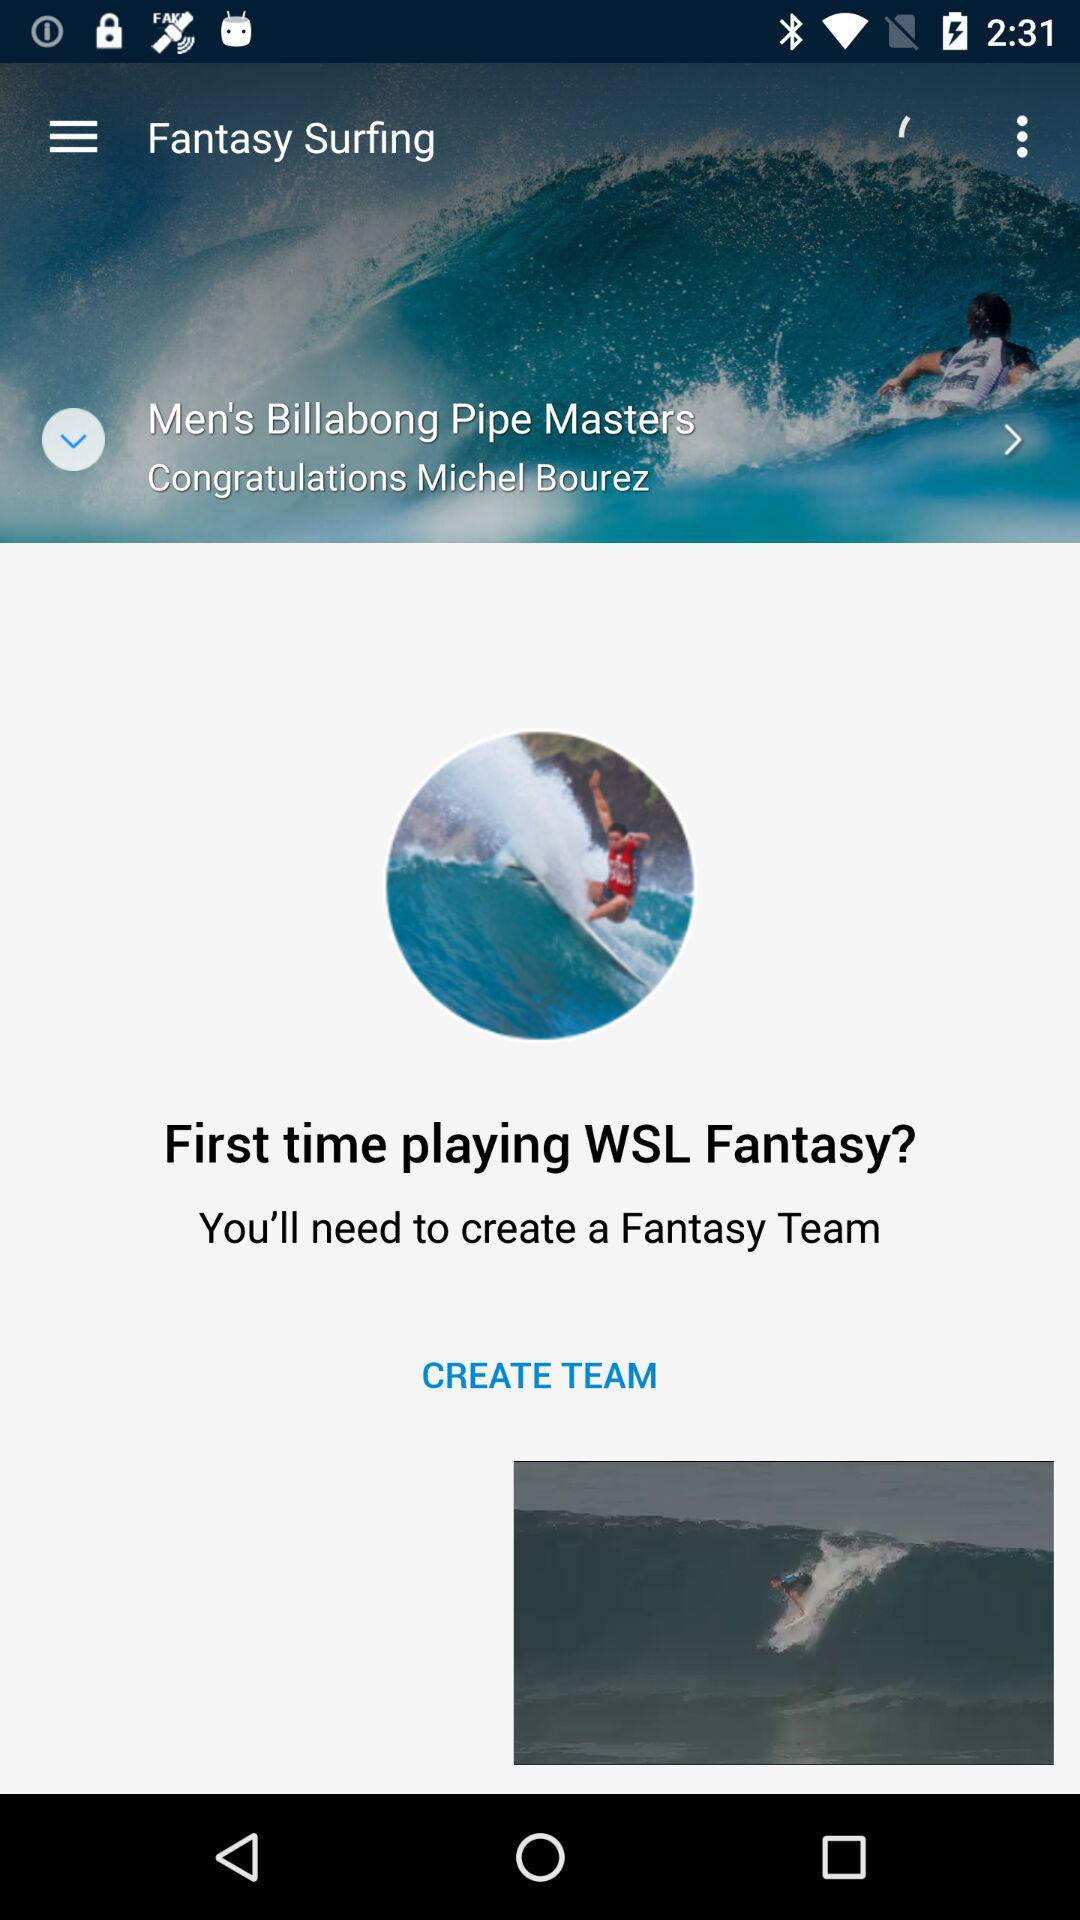Who won the "Men's Billabong Pipe Masters"? The "Men's Billabong Pipe Masters" is won by Michel Bourez. 